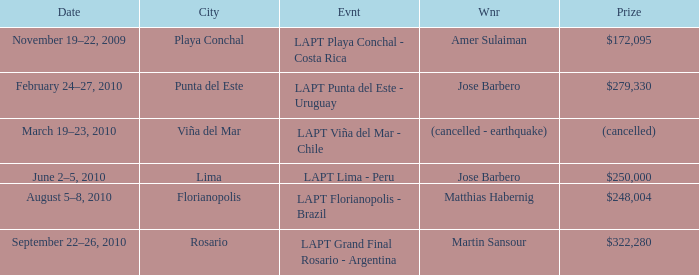What is the date amer sulaiman won? November 19–22, 2009. 